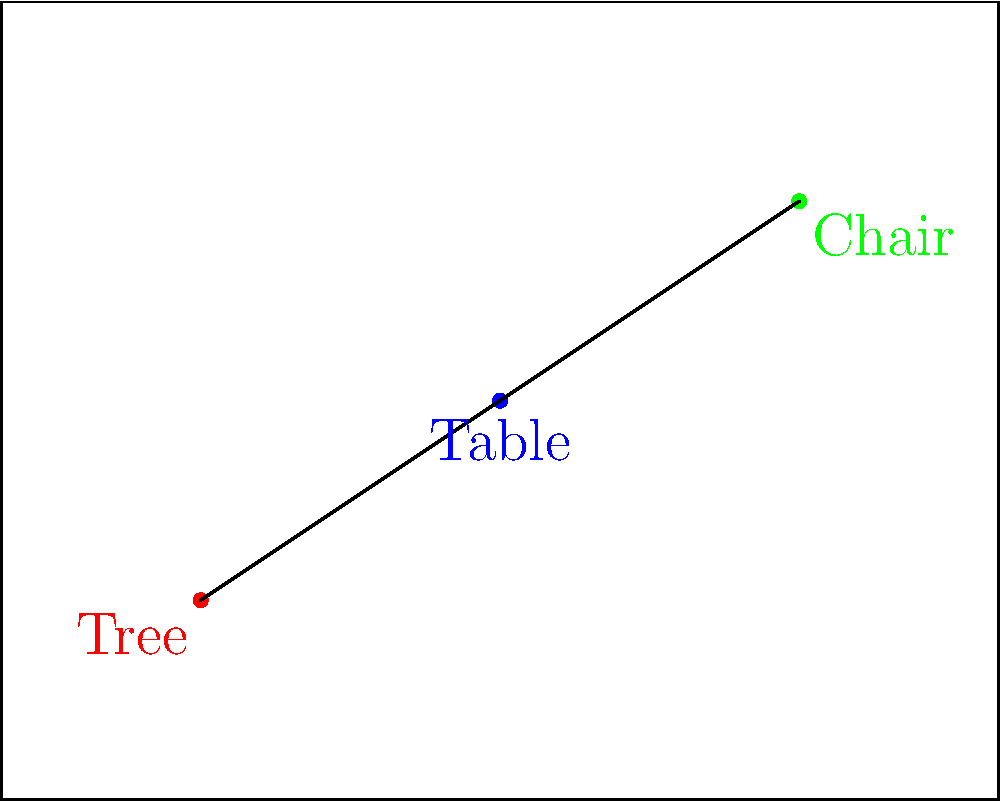For your child's first-grade play, you need to arrange three props on the stage: a tree, a table, and a chair. Given the limited stage area shown in the diagram, what shape does the optimal arrangement of these props form to maximize visibility and movement space for the young actors? To determine the optimal arrangement of props for a first-grade play, we need to consider several factors:

1. Visibility: The props should be arranged so that they don't obstruct the audience's view of the young actors.
2. Movement space: There should be enough room for the children to move around safely and comfortably.
3. Stage coverage: The props should be distributed across the stage to create a balanced set.

Looking at the diagram:

1. The tree (red dot) is placed near the front left corner of the stage.
2. The table (blue dot) is positioned in the center of the stage.
3. The chair (green dot) is located towards the back right of the stage.

When we connect these three points, we can see that they form a triangle. This triangular arrangement is optimal because:

a) It creates clear paths between the props for the actors to move.
b) It distributes the props across the stage, utilizing the space efficiently.
c) It allows for good visibility from different angles in the audience.
d) The triangle shape provides stability and balance to the overall set design.

This arrangement also allows for flexibility in blocking (positioning actors on stage) and creates natural focal points for different scenes in the play.
Answer: Triangle 